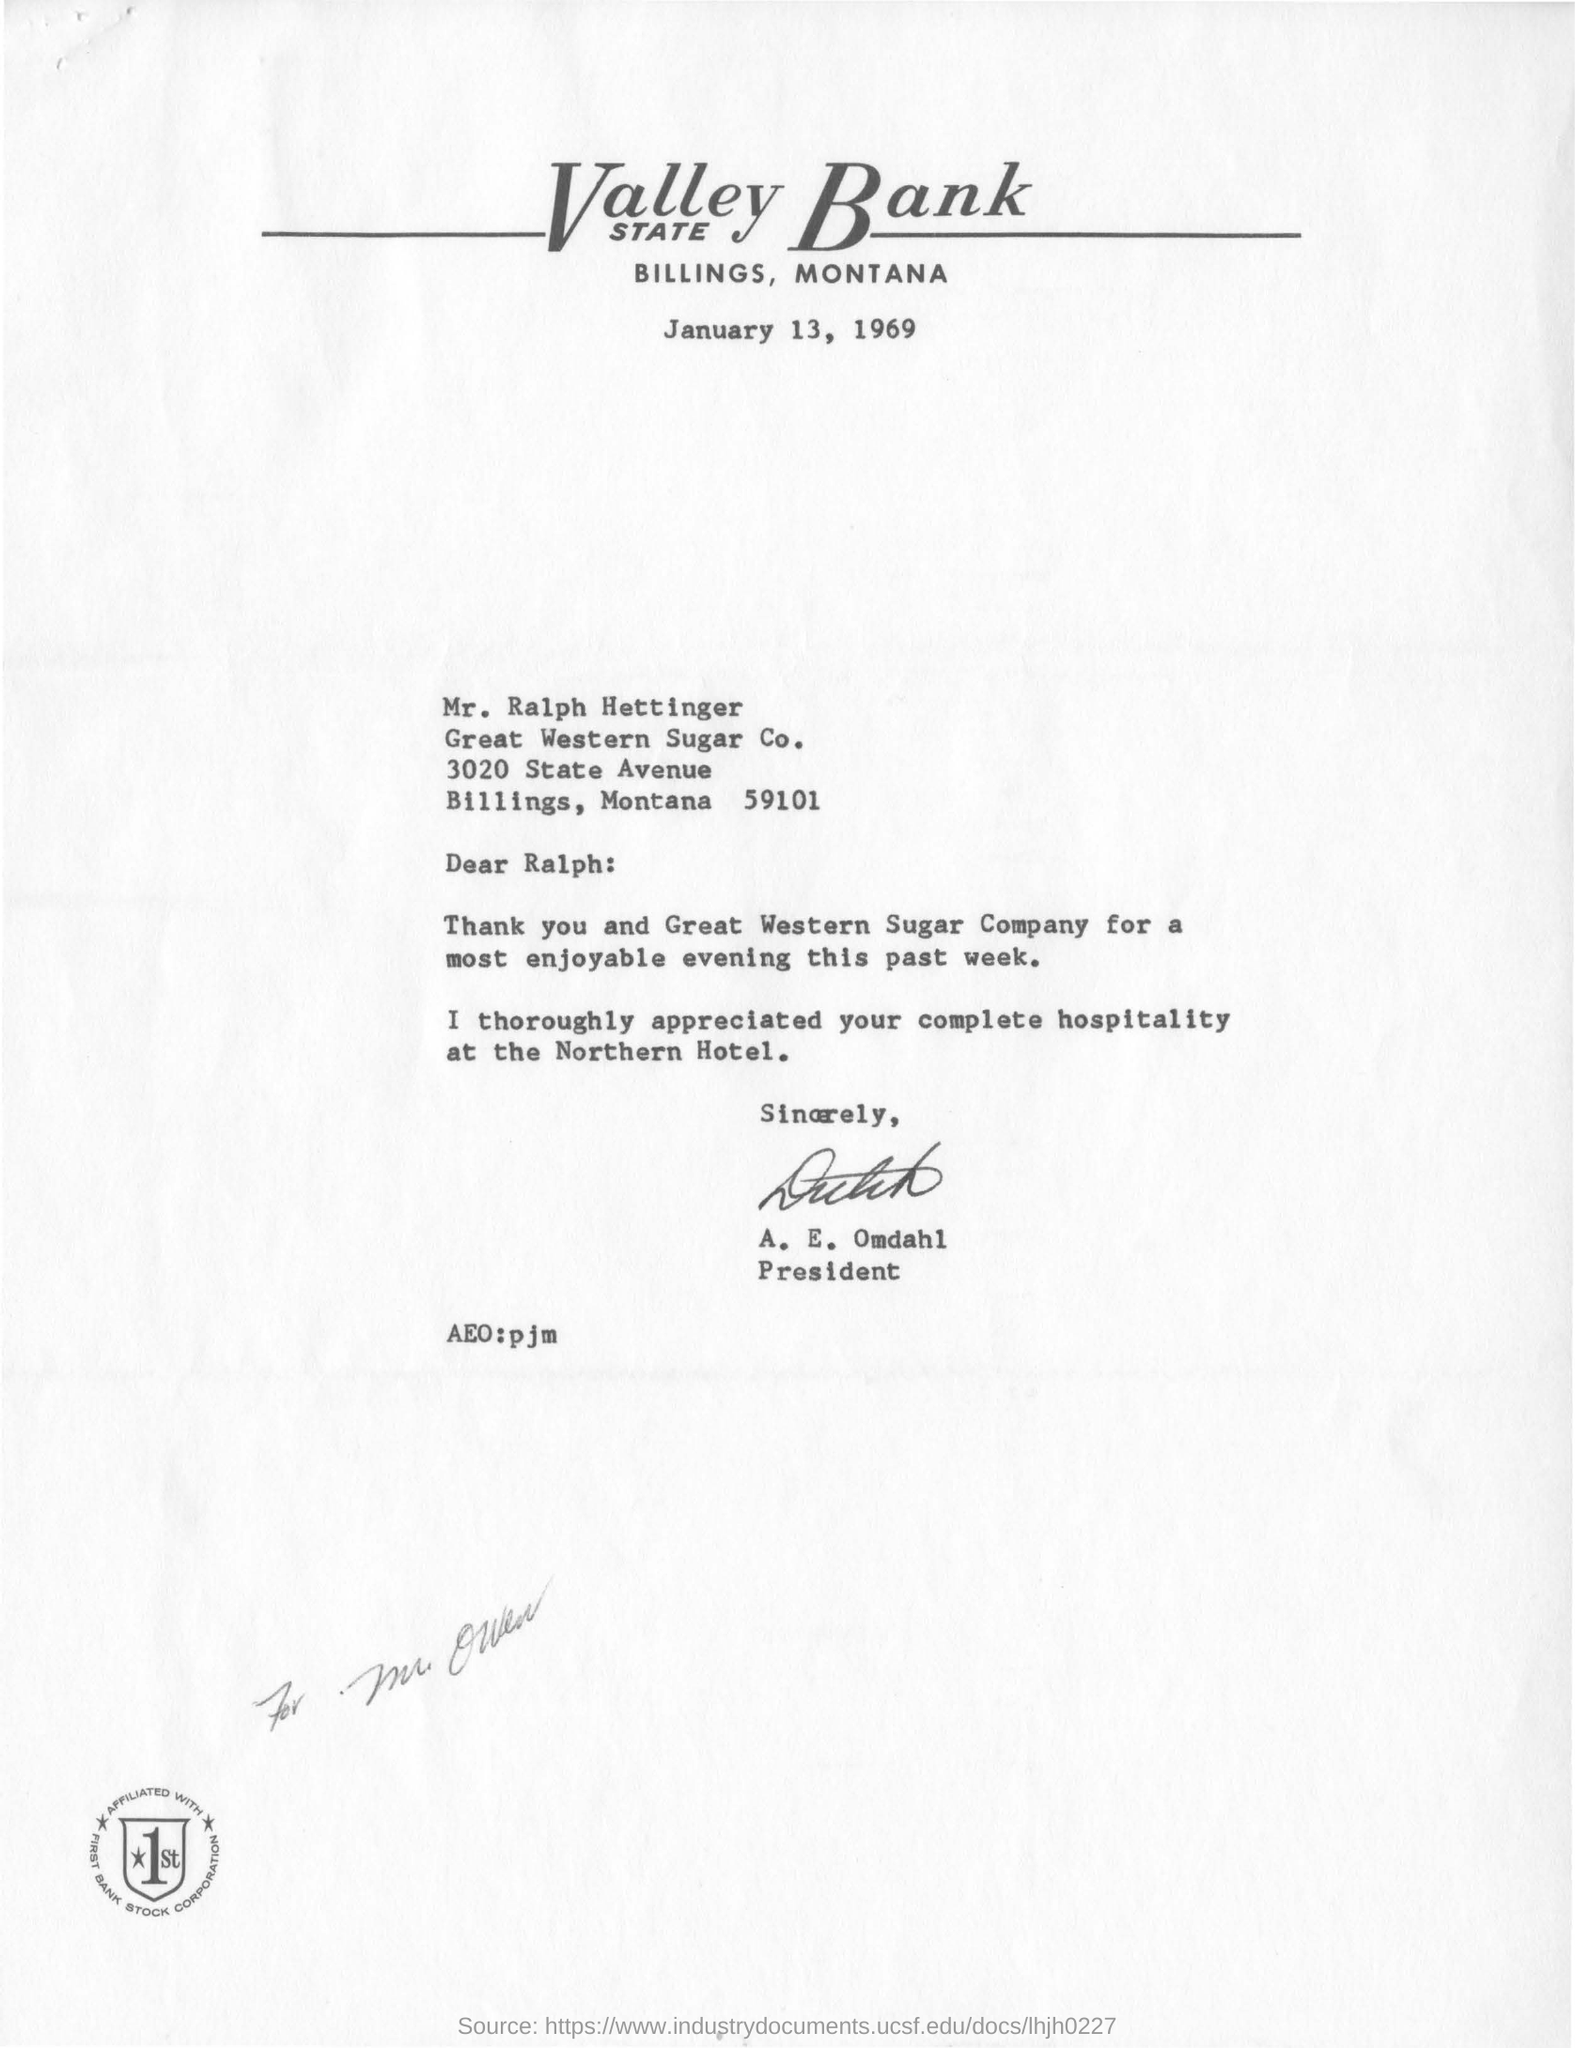To Whom is this letter addressed to?
Give a very brief answer. Mr. Ralph Hettinger. Who is this letter from?
Provide a short and direct response. A. E. Omdahl. Who has signed this letter?
Your response must be concise. A. E. Omdahl. What is the date on the letter?
Give a very brief answer. January 13, 1969. 